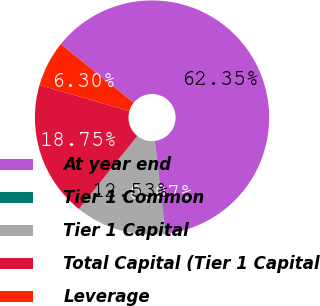Convert chart to OTSL. <chart><loc_0><loc_0><loc_500><loc_500><pie_chart><fcel>At year end<fcel>Tier 1 Common<fcel>Tier 1 Capital<fcel>Total Capital (Tier 1 Capital<fcel>Leverage<nl><fcel>62.35%<fcel>0.07%<fcel>12.53%<fcel>18.75%<fcel>6.3%<nl></chart> 